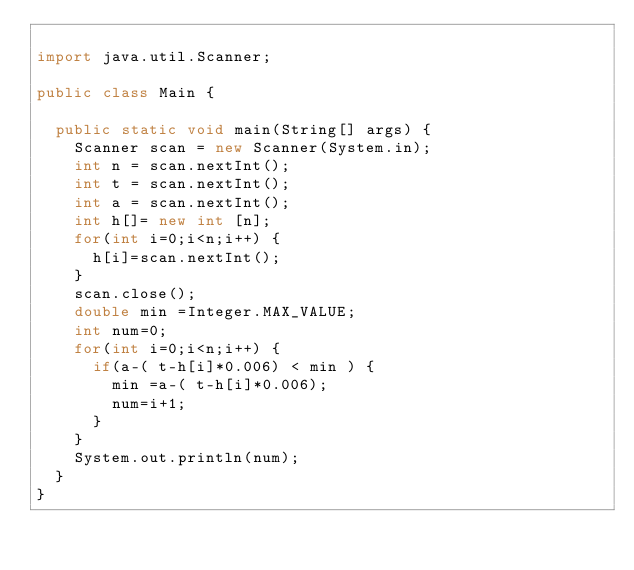Convert code to text. <code><loc_0><loc_0><loc_500><loc_500><_Java_>
import java.util.Scanner;

public class Main {

	public static void main(String[] args) {
		Scanner scan = new Scanner(System.in);
		int n = scan.nextInt();
		int t = scan.nextInt();
		int a = scan.nextInt();
		int h[]= new int [n];
		for(int i=0;i<n;i++) {
			h[i]=scan.nextInt();
		}
		scan.close();
		double min =Integer.MAX_VALUE;
		int num=0;
		for(int i=0;i<n;i++) {
			if(a-( t-h[i]*0.006) < min ) {
				min =a-( t-h[i]*0.006);
				num=i+1;
			}
		}
		System.out.println(num);
	}
}</code> 